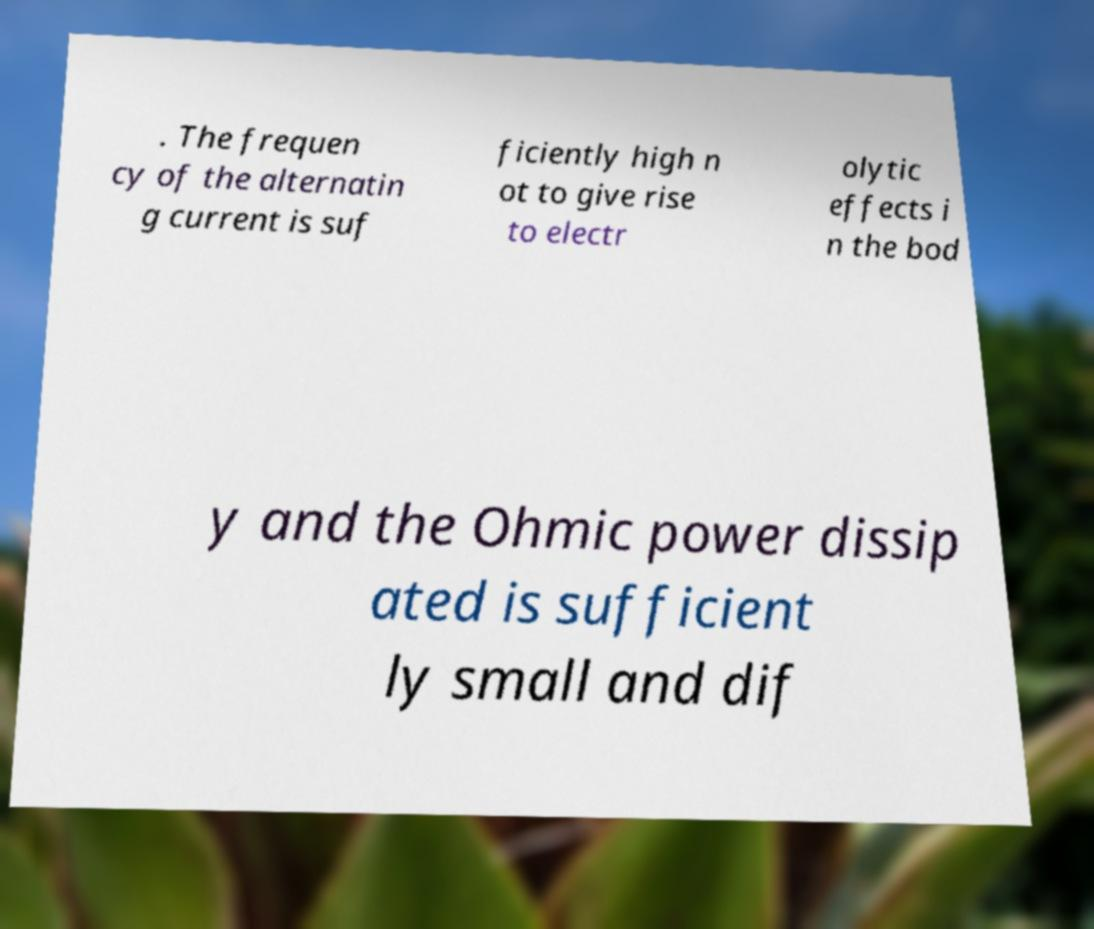For documentation purposes, I need the text within this image transcribed. Could you provide that? . The frequen cy of the alternatin g current is suf ficiently high n ot to give rise to electr olytic effects i n the bod y and the Ohmic power dissip ated is sufficient ly small and dif 